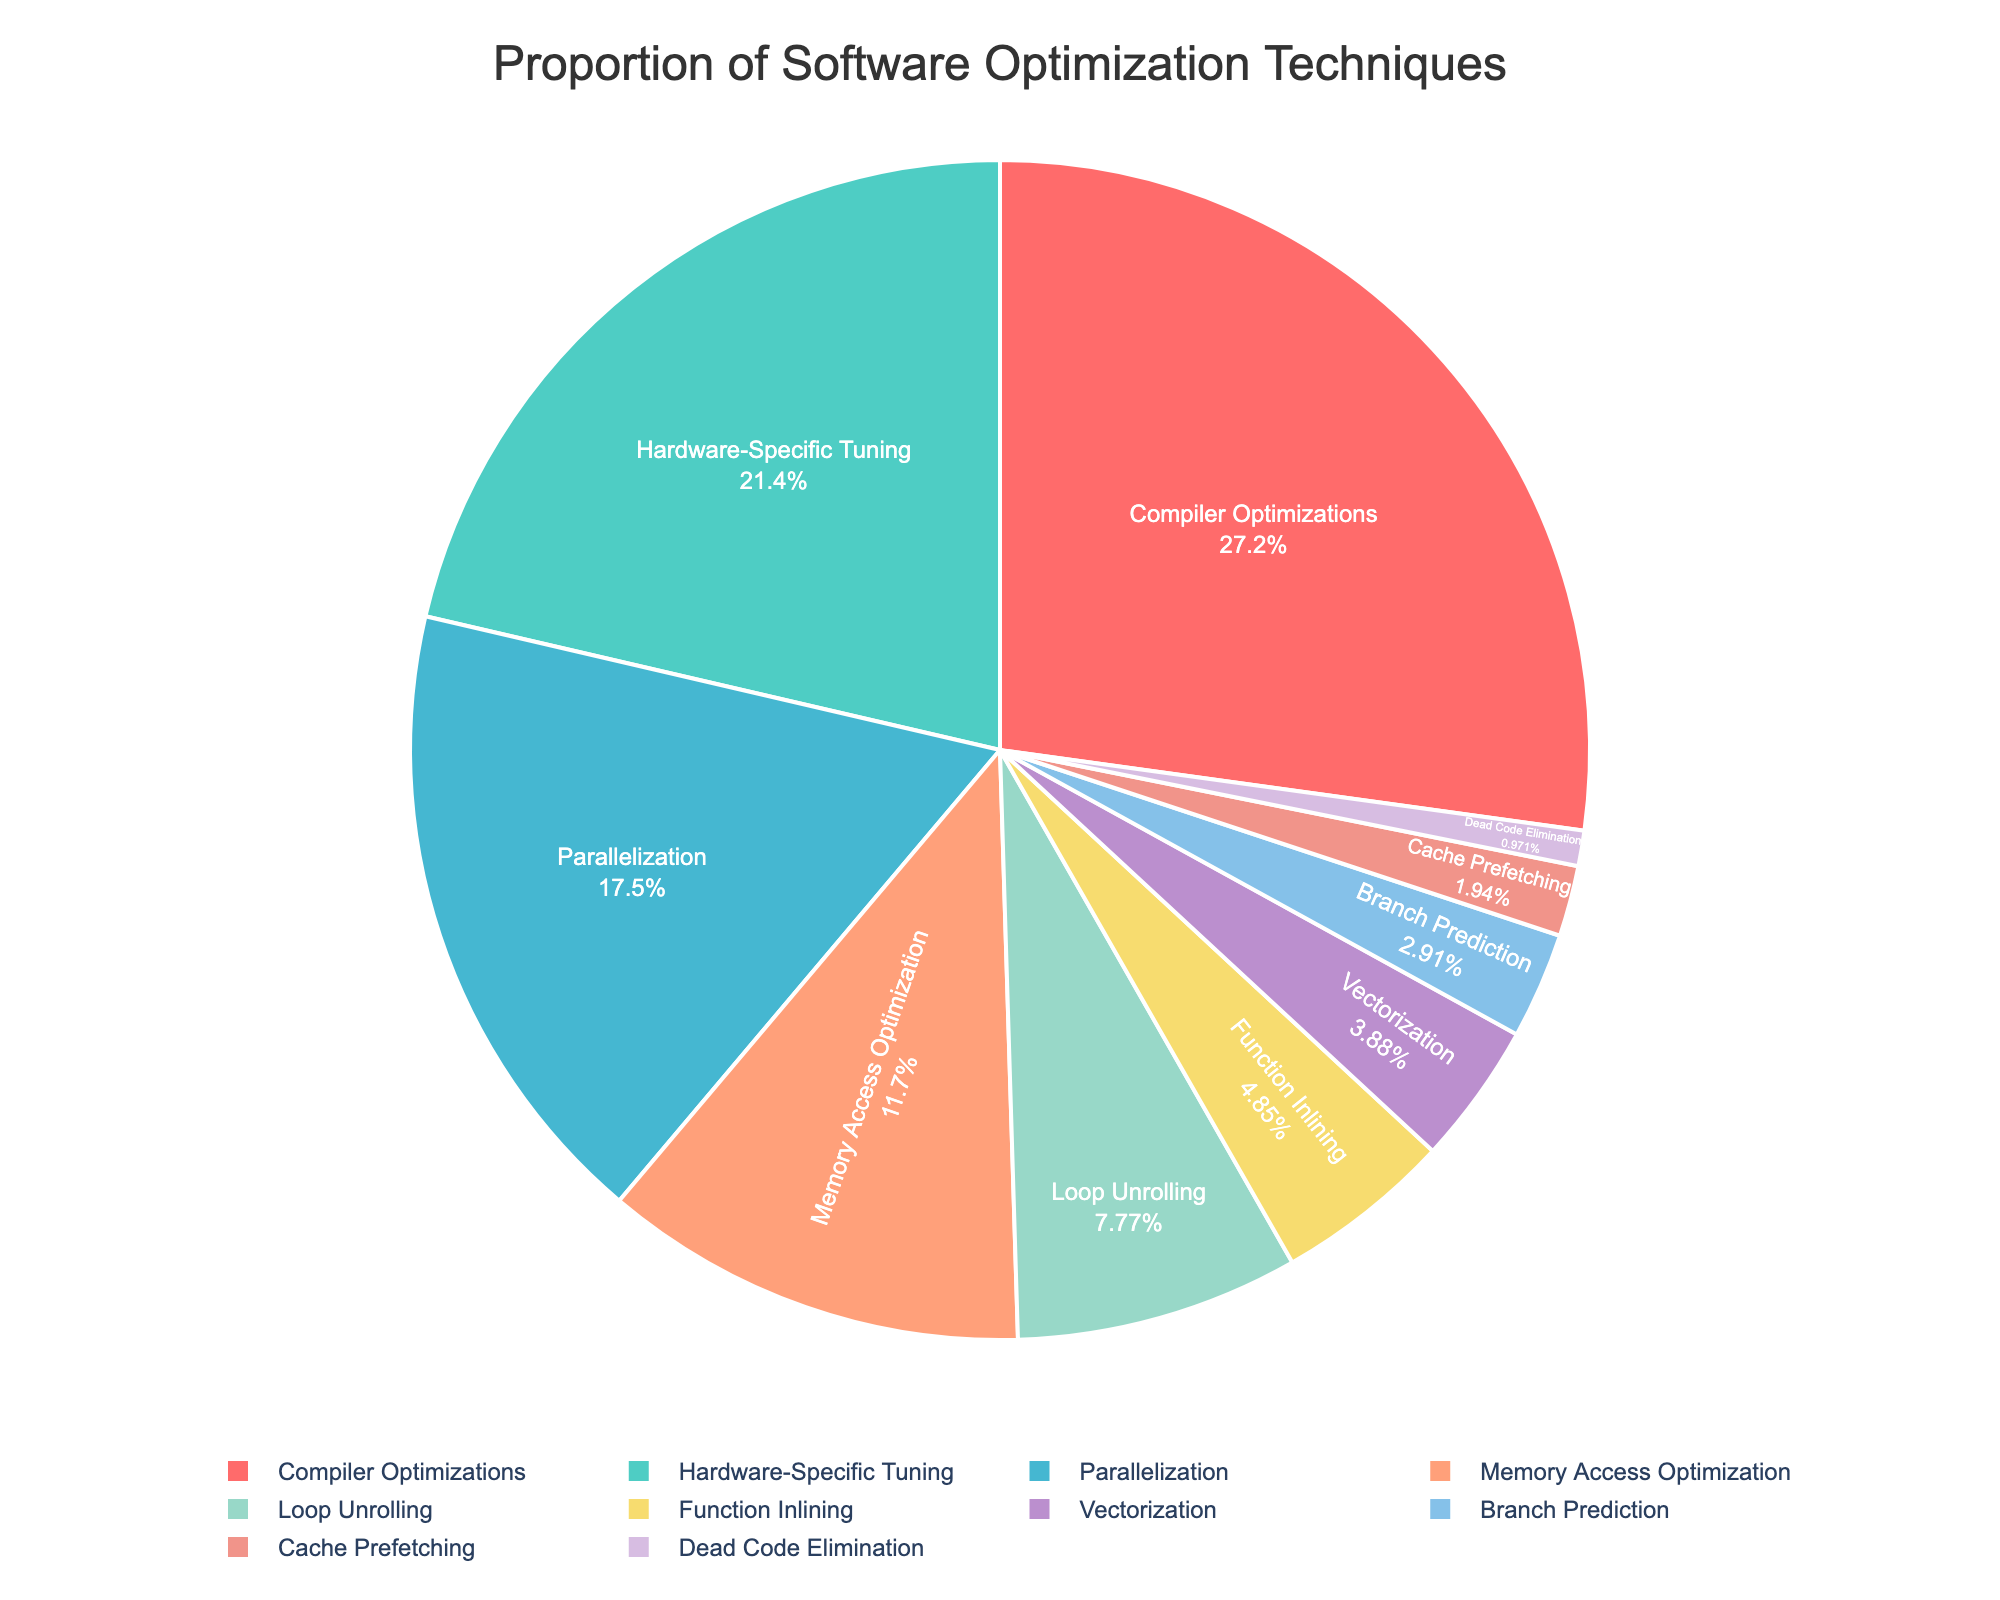Which technique has the highest percentage in the pie chart? The technique with the highest percentage can be identified by looking for the largest section of the pie chart. Compiler Optimizations occupies the largest section.
Answer: Compiler Optimizations What is the total percentage of Compiler Optimizations and Parallelization combined? To find the total, add the percentage of Compiler Optimizations (28%) and Parallelization (18%). Thus, the total is 28% + 18% = 46%.
Answer: 46% Which two techniques together contribute to exactly 20% of the total? To find the combination that sums up to 20%, check the percentages of each technique. Loop Unrolling (8%) and Function Inlining (5%) together do not make 20%. Vectorization (4%) and Branch Prediction (3%) also do not make 20%. Loop Unrolling (8%) and Memory Access Optimization (12%) together make 20%.
Answer: Loop Unrolling and Memory Access Optimization How much greater is Compiler Optimizations compared to Dead Code Elimination? Subtract the percentage of Dead Code Elimination (1%) from Compiler Optimizations (28%). The difference is 28% - 1% = 27%.
Answer: 27% Which technique is represented by a green section in the pie chart? Identify the section of the pie chart that is colored green. Hardware-Specific Tuning is represented by a green section.
Answer: Hardware-Specific Tuning What is the combined percentage of techniques that have a percentage less than 5%? Identify techniques with less than 5%: Vectorization (4%), Branch Prediction (3%), Cache Prefetching (2%), and Dead Code Elimination (1%). Sum these percentages: 4% + 3% + 2% + 1% = 10%.
Answer: 10% How much more does Hardware-Specific Tuning contribute compared to Memory Access Optimization? Subtract the percentage of Memory Access Optimization (12%) from Hardware-Specific Tuning (22%). The difference is 22% - 12% = 10%.
Answer: 10% Which technique has the smallest section in the pie chart? The smallest section corresponds to the technique with the lowest percentage. Dead Code Elimination holds the smallest section with 1%.
Answer: Dead Code Elimination What is the combined percentage of all techniques except for Compiler Optimizations and Hardware-Specific Tuning? Subtract the percentages of Compiler Optimizations (28%) and Hardware-Specific Tuning (22%) from 100%. The total is 100% - 28% - 22% = 50%.
Answer: 50% Which techniques occupy red and purple sections respectively in the pie chart? Identify the colors of the pie sections representing red and purple. Red corresponds to Compiler Optimizations and purple corresponds to Vectorization.
Answer: Compiler Optimizations and Vectorization 